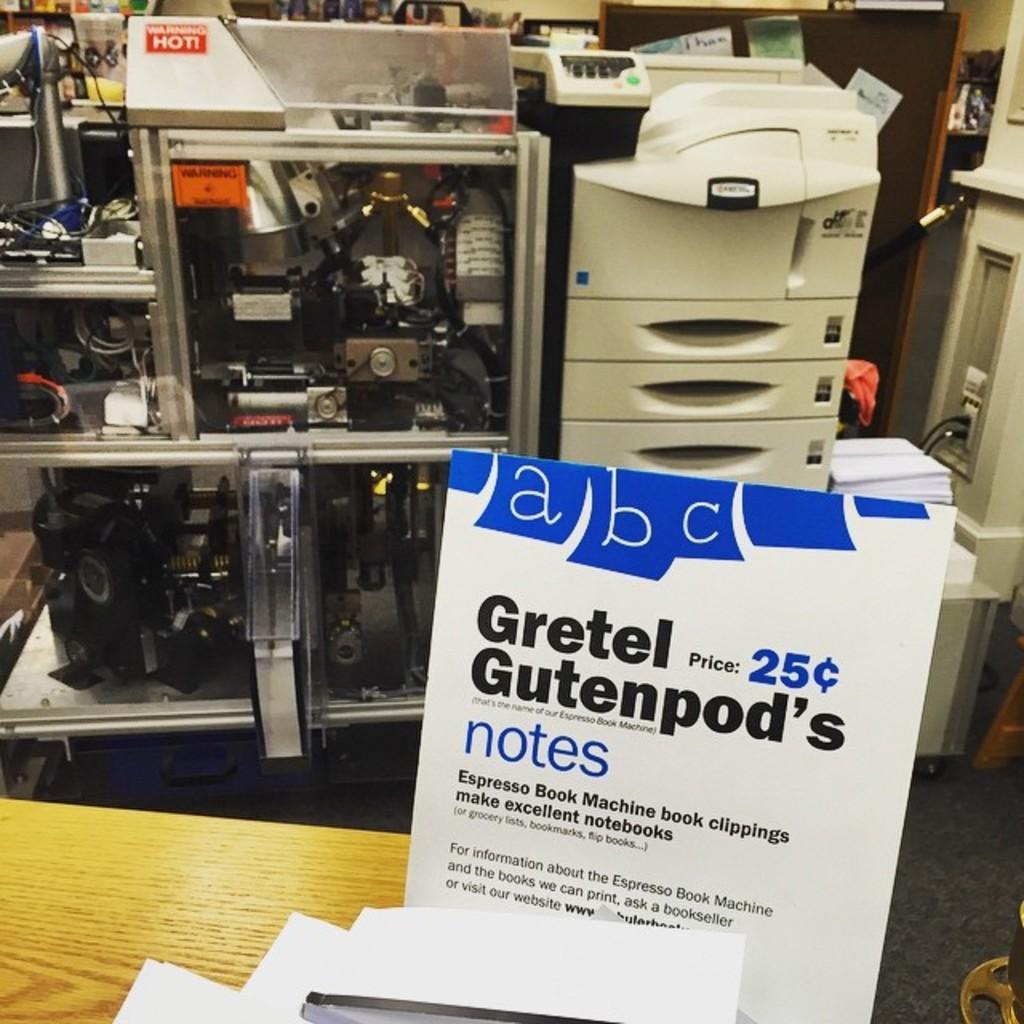How would you summarize this image in a sentence or two? In this picture there is a board and there are papers on the table. At the back there are machines and devices and there are papers on the machine. 